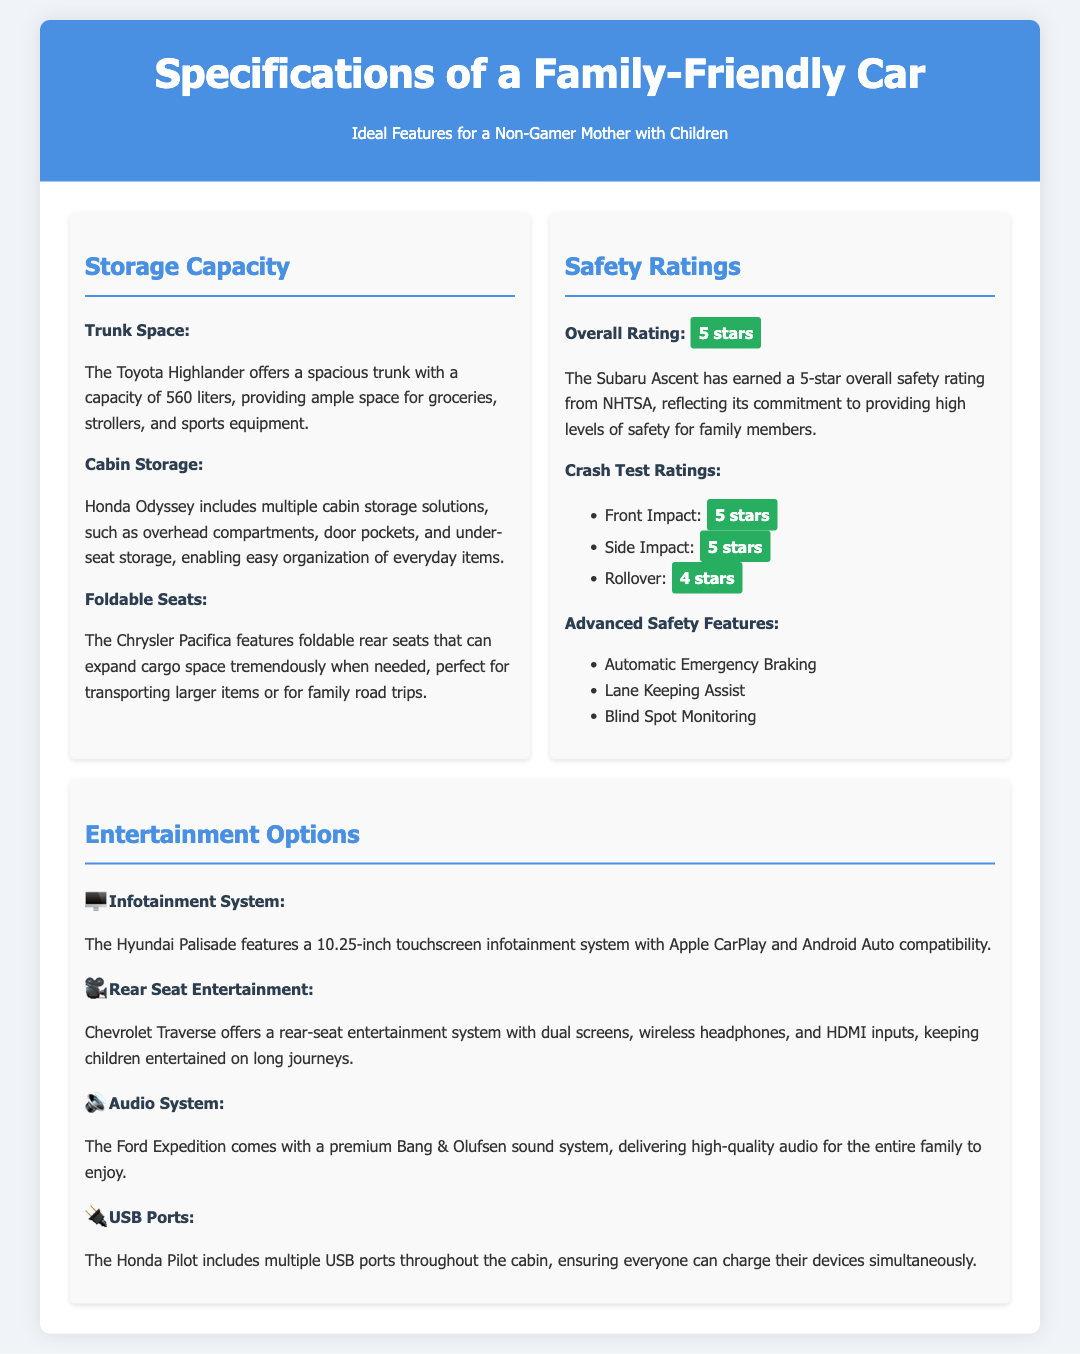What is the trunk space capacity of the Toyota Highlander? The trunk space capacity of the Toyota Highlander is mentioned in the document as 560 liters.
Answer: 560 liters Which car has a 5-star overall safety rating? The Subaru Ascent is highlighted in the document as having a 5-star overall safety rating.
Answer: Subaru Ascent What advanced safety feature is included in the document? The document lists several advanced safety features; one of them is Automatic Emergency Braking.
Answer: Automatic Emergency Braking What is the screen size of the Hyundai Palisade's infotainment system? The screen size of the Hyundai Palisade's infotainment system, as stated in the document, is 10.25 inches.
Answer: 10.25 inches How many USB ports are there in the Honda Pilot? The document mentions that the Honda Pilot includes multiple USB ports throughout the cabin, but does not specify the exact number.
Answer: Multiple What entertainment option is offered by the Chevrolet Traverse? The document states that the Chevrolet Traverse offers a rear-seat entertainment system with dual screens.
Answer: Rear-seat entertainment system with dual screens Which vehicle features foldable rear seats for expanded cargo space? The Chrysler Pacifica is specifically mentioned for having foldable rear seats to expand cargo space.
Answer: Chrysler Pacifica What is the entertainment system brand in the Ford Expedition? The document indicates that the Ford Expedition comes with a premium Bang & Olufsen sound system.
Answer: Bang & Olufsen What type of impact did the Subaru Ascent receive a 5-star rating for? The document details that the Subaru Ascent received a 5-star rating for Front Impact.
Answer: Front Impact 